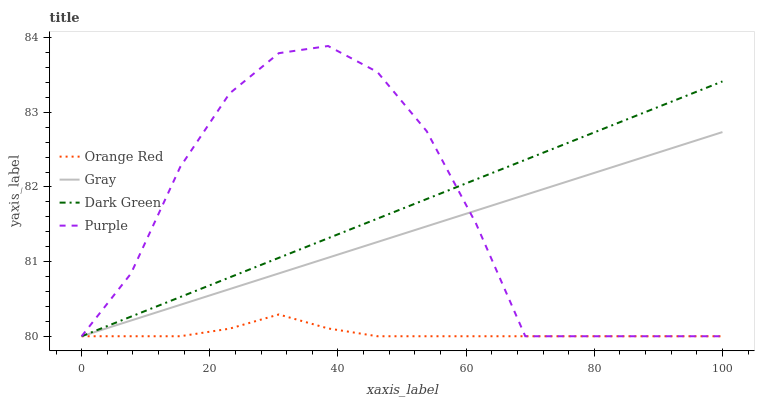Does Orange Red have the minimum area under the curve?
Answer yes or no. Yes. Does Dark Green have the maximum area under the curve?
Answer yes or no. Yes. Does Gray have the minimum area under the curve?
Answer yes or no. No. Does Gray have the maximum area under the curve?
Answer yes or no. No. Is Dark Green the smoothest?
Answer yes or no. Yes. Is Purple the roughest?
Answer yes or no. Yes. Is Gray the smoothest?
Answer yes or no. No. Is Gray the roughest?
Answer yes or no. No. Does Purple have the lowest value?
Answer yes or no. Yes. Does Purple have the highest value?
Answer yes or no. Yes. Does Gray have the highest value?
Answer yes or no. No. Does Purple intersect Orange Red?
Answer yes or no. Yes. Is Purple less than Orange Red?
Answer yes or no. No. Is Purple greater than Orange Red?
Answer yes or no. No. 